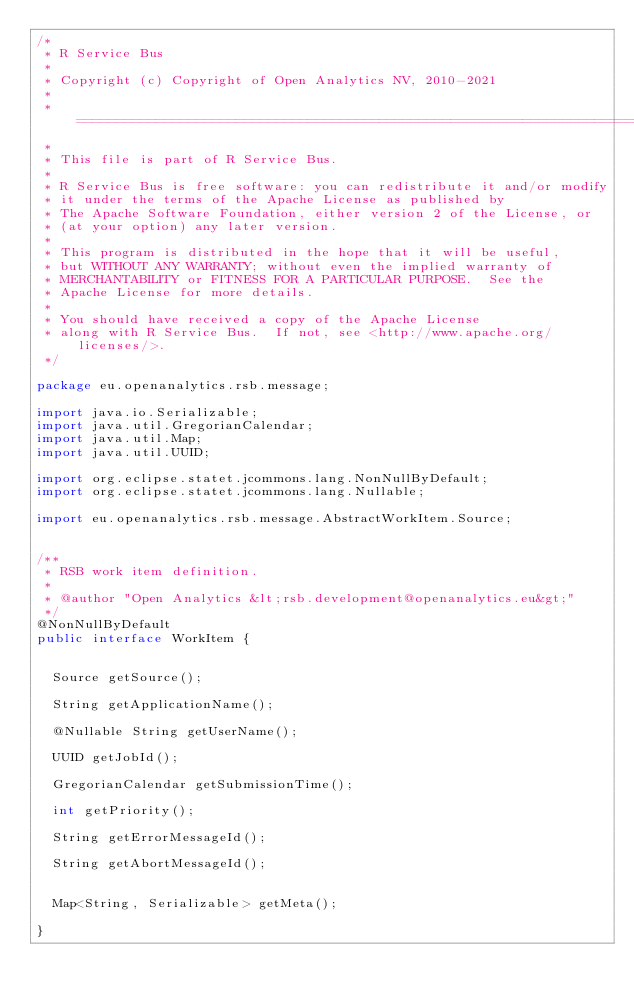Convert code to text. <code><loc_0><loc_0><loc_500><loc_500><_Java_>/*
 * R Service Bus
 * 
 * Copyright (c) Copyright of Open Analytics NV, 2010-2021
 * 
 * ===========================================================================
 * 
 * This file is part of R Service Bus.
 * 
 * R Service Bus is free software: you can redistribute it and/or modify
 * it under the terms of the Apache License as published by
 * The Apache Software Foundation, either version 2 of the License, or
 * (at your option) any later version.
 * 
 * This program is distributed in the hope that it will be useful,
 * but WITHOUT ANY WARRANTY; without even the implied warranty of
 * MERCHANTABILITY or FITNESS FOR A PARTICULAR PURPOSE.  See the
 * Apache License for more details.
 * 
 * You should have received a copy of the Apache License
 * along with R Service Bus.  If not, see <http://www.apache.org/licenses/>.
 */

package eu.openanalytics.rsb.message;

import java.io.Serializable;
import java.util.GregorianCalendar;
import java.util.Map;
import java.util.UUID;

import org.eclipse.statet.jcommons.lang.NonNullByDefault;
import org.eclipse.statet.jcommons.lang.Nullable;

import eu.openanalytics.rsb.message.AbstractWorkItem.Source;


/**
 * RSB work item definition.
 * 
 * @author "Open Analytics &lt;rsb.development@openanalytics.eu&gt;"
 */
@NonNullByDefault
public interface WorkItem {
	
	
	Source getSource();
	
	String getApplicationName();
	
	@Nullable String getUserName();
	
	UUID getJobId();
	
	GregorianCalendar getSubmissionTime();
	
	int getPriority();
	
	String getErrorMessageId();
	
	String getAbortMessageId();
	
	
	Map<String, Serializable> getMeta();
	
}
</code> 